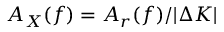Convert formula to latex. <formula><loc_0><loc_0><loc_500><loc_500>A _ { X } ( f ) = A _ { r } ( f ) / | \Delta K |</formula> 